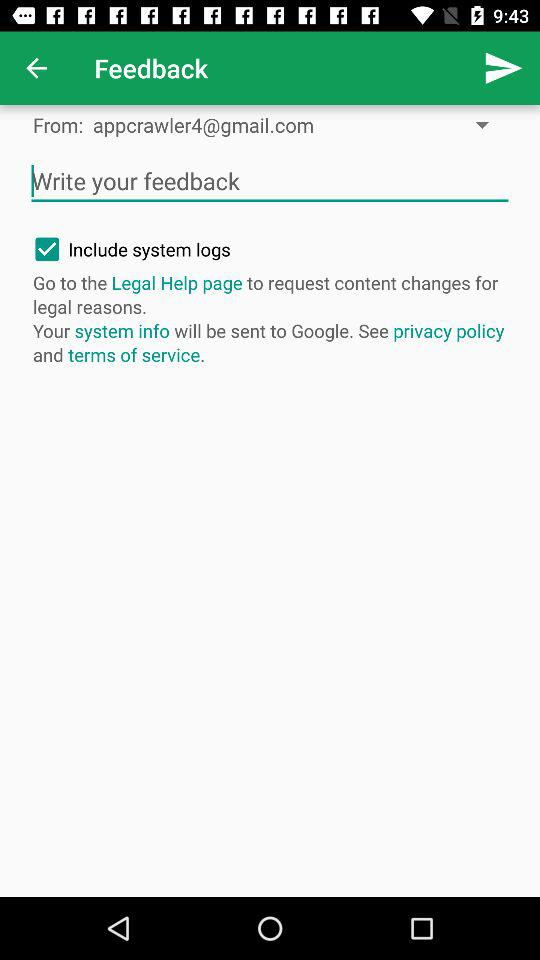What is the status of "Include system logs"? The status is "on". 